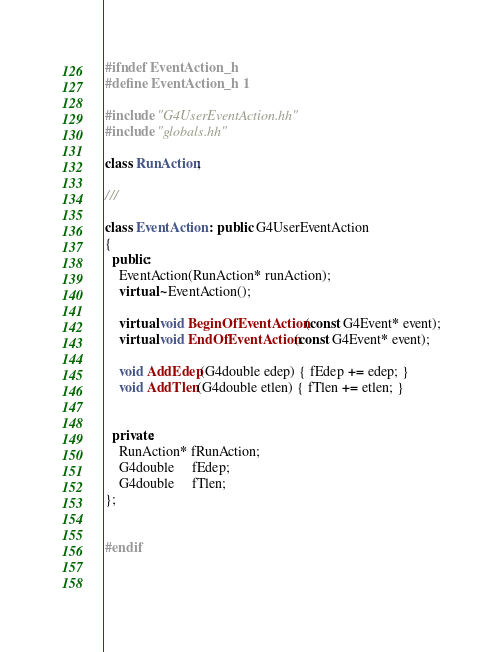<code> <loc_0><loc_0><loc_500><loc_500><_C++_>

#ifndef EventAction_h
#define EventAction_h 1

#include "G4UserEventAction.hh"
#include "globals.hh"

class RunAction;

///

class EventAction : public G4UserEventAction
{
  public:
    EventAction(RunAction* runAction);
    virtual ~EventAction();

    virtual void BeginOfEventAction(const G4Event* event);
    virtual void EndOfEventAction(const G4Event* event);

    void AddEdep(G4double edep) { fEdep += edep; }
    void AddTlen(G4double etlen) { fTlen += etlen; }


  private:
    RunAction* fRunAction;
    G4double     fEdep;
    G4double     fTlen;  
};


#endif

    
</code> 